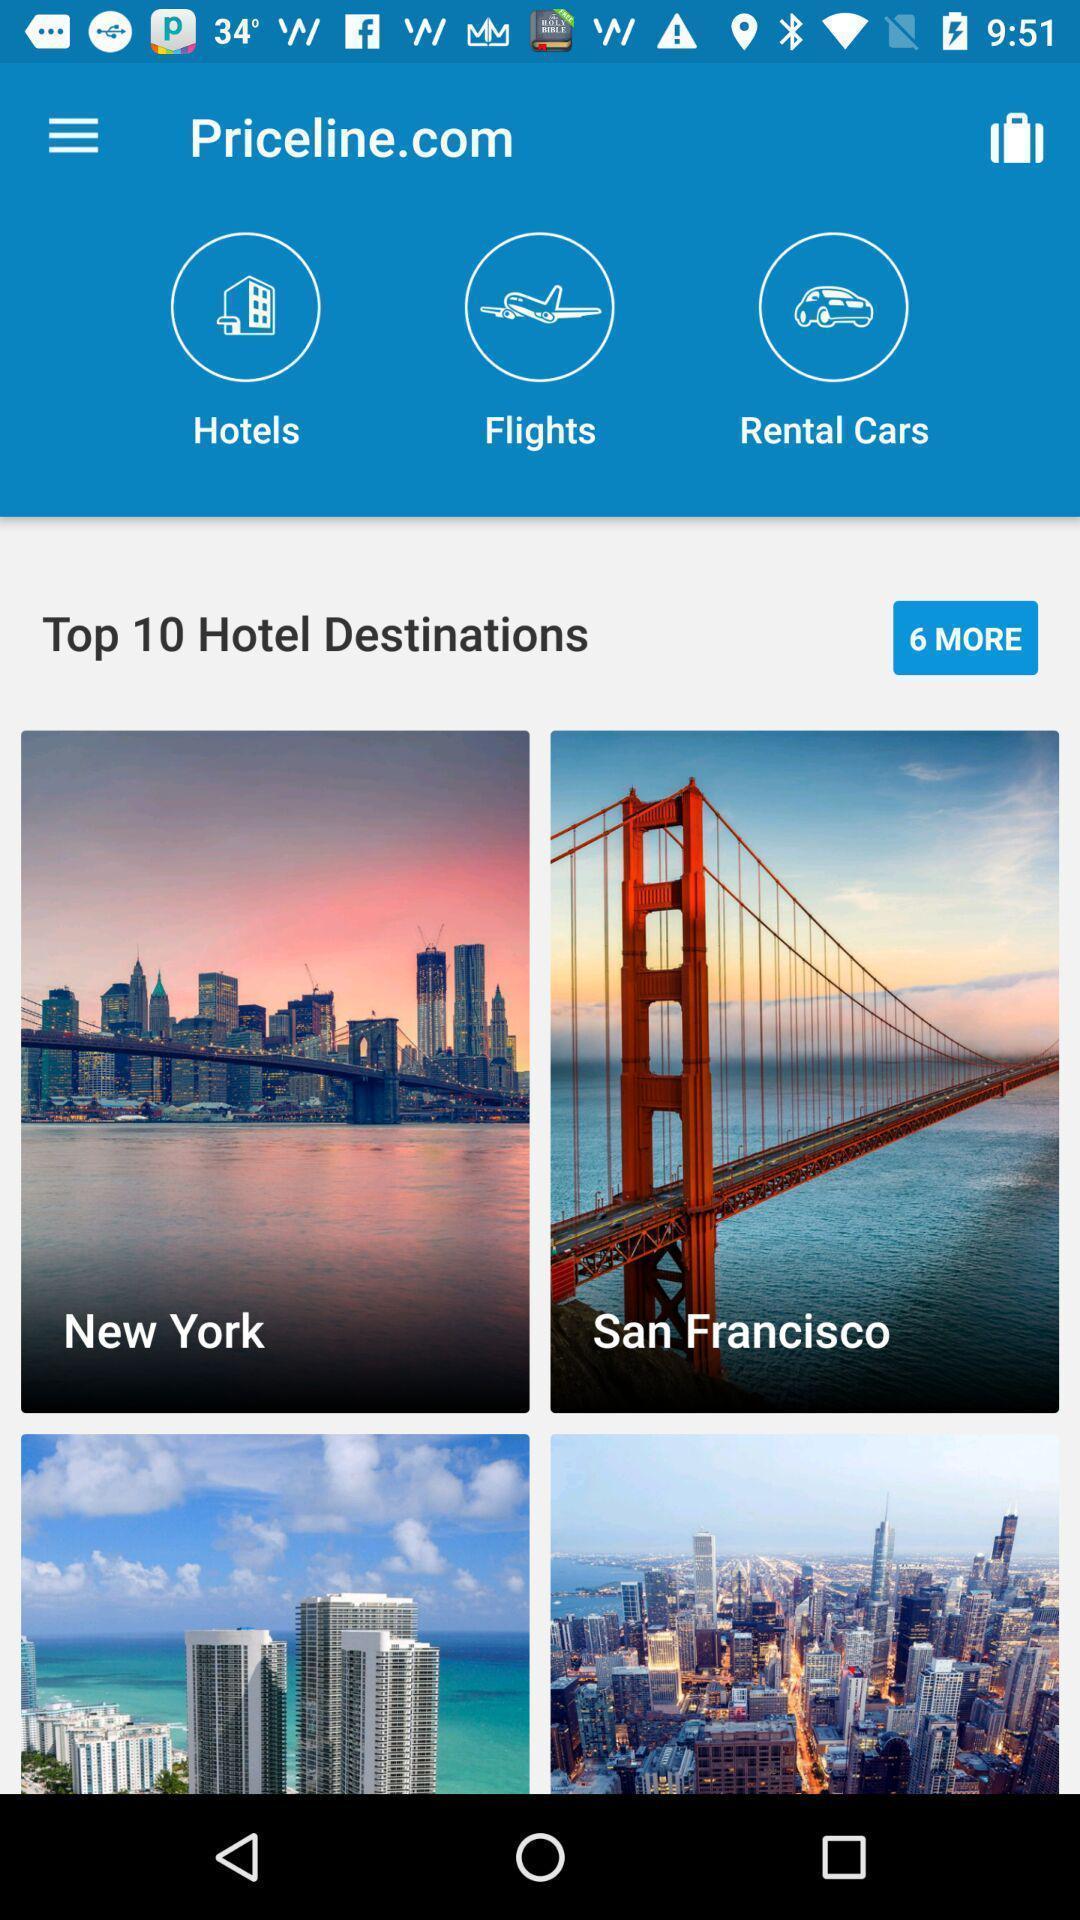Summarize the main components in this picture. Page of a travelling app. 